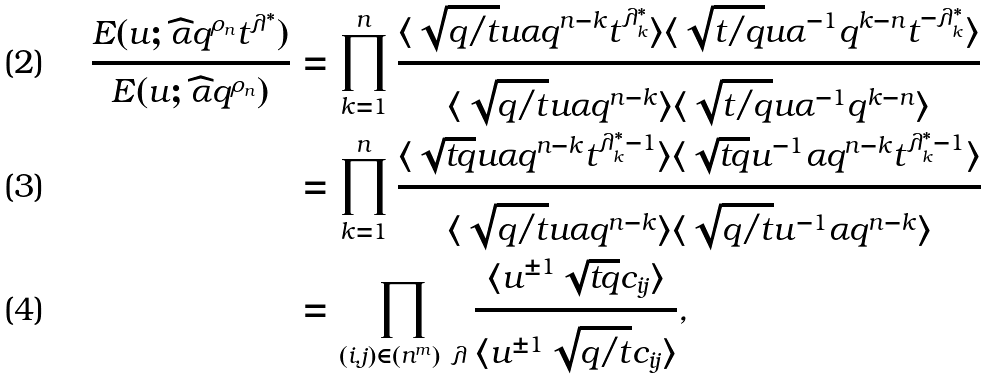Convert formula to latex. <formula><loc_0><loc_0><loc_500><loc_500>\frac { E ( u ; \widehat { \alpha } q ^ { \rho _ { n } } t ^ { \lambda ^ { * } } ) } { E ( u ; \widehat { \alpha } q ^ { \rho _ { n } } ) } & = \prod _ { k = 1 } ^ { n } \frac { \langle \sqrt { q / t } u \alpha q ^ { n - k } t ^ { \lambda _ { k } ^ { * } } \rangle \langle \sqrt { t / q } u \alpha ^ { - 1 } q ^ { k - n } t ^ { - \lambda _ { k } ^ { * } } \rangle } { \langle \sqrt { q / t } u \alpha q ^ { n - k } \rangle \langle \sqrt { t / q } u \alpha ^ { - 1 } q ^ { k - n } \rangle } \\ & = \prod _ { k = 1 } ^ { n } \frac { \langle \sqrt { t q } u \alpha q ^ { n - k } t ^ { \lambda _ { k } ^ { * } - 1 } \rangle \langle \sqrt { t q } u ^ { - 1 } \alpha q ^ { n - k } t ^ { \lambda _ { k } ^ { * } - 1 } \rangle } { \langle \sqrt { q / t } u \alpha q ^ { n - k } \rangle \langle \sqrt { q / t } u ^ { - 1 } \alpha q ^ { n - k } \rangle } \\ & = \prod _ { ( i , j ) \in ( n ^ { m } ) \ \lambda } \frac { \langle u ^ { \pm 1 } \sqrt { t q } c _ { i j } \rangle } { \langle u ^ { \pm 1 } \sqrt { q / t } c _ { i j } \rangle } ,</formula> 